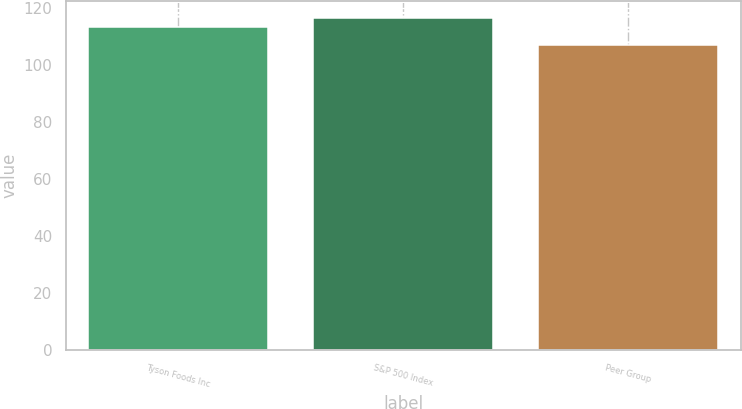Convert chart. <chart><loc_0><loc_0><loc_500><loc_500><bar_chart><fcel>Tyson Foods Inc<fcel>S&P 500 Index<fcel>Peer Group<nl><fcel>113.35<fcel>116.44<fcel>106.89<nl></chart> 